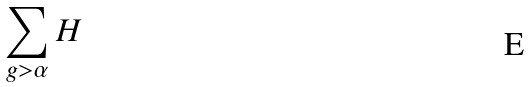Convert formula to latex. <formula><loc_0><loc_0><loc_500><loc_500>\sum _ { g > \alpha } { H }</formula> 